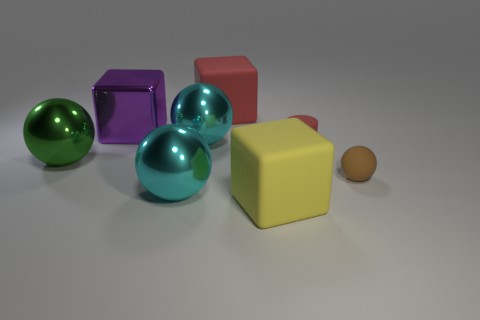Are there any other things that are the same shape as the small red matte object?
Offer a very short reply. No. What number of red things are matte cylinders or big rubber cubes?
Provide a succinct answer. 2. How many metallic objects are either spheres or tiny blue objects?
Offer a very short reply. 3. Is there a tiny metallic ball?
Your response must be concise. No. Is the shape of the brown object the same as the big green thing?
Ensure brevity in your answer.  Yes. How many red cylinders are behind the red thing that is on the right side of the cube that is in front of the small brown thing?
Make the answer very short. 0. What is the material of the sphere that is both in front of the large green thing and to the left of the brown matte thing?
Offer a very short reply. Metal. What is the color of the matte thing that is behind the brown matte thing and in front of the big shiny cube?
Make the answer very short. Red. Is there anything else that is the same color as the matte ball?
Your answer should be very brief. No. The red thing that is behind the metallic thing that is on the right side of the large cyan metal sphere that is in front of the tiny red thing is what shape?
Your response must be concise. Cube. 